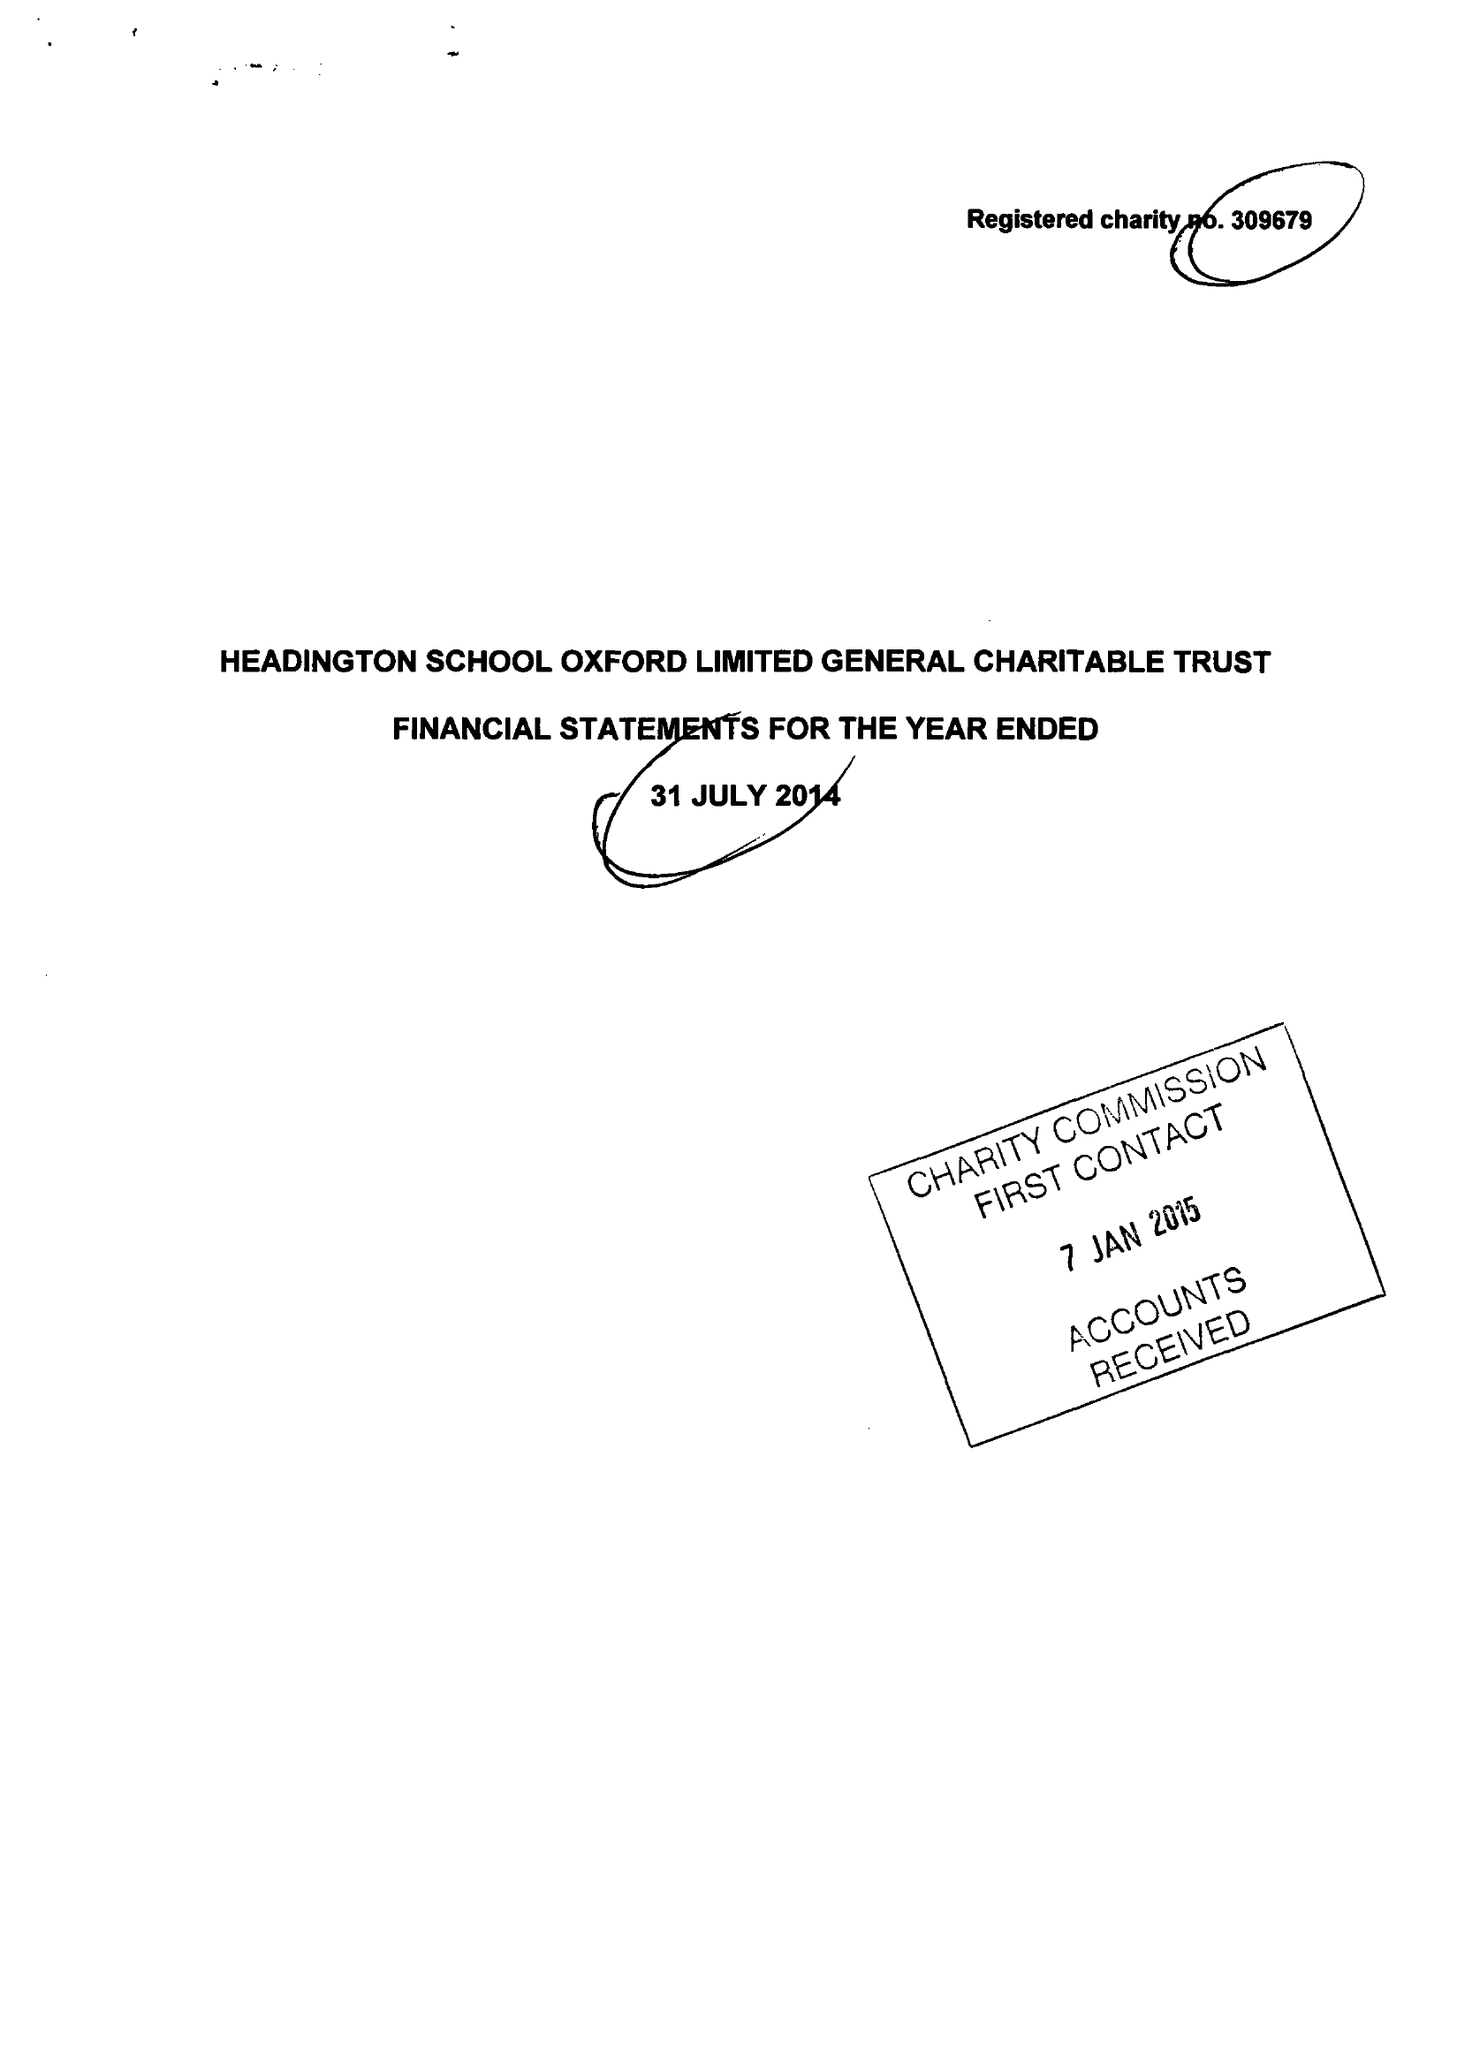What is the value for the charity_number?
Answer the question using a single word or phrase. 309679 